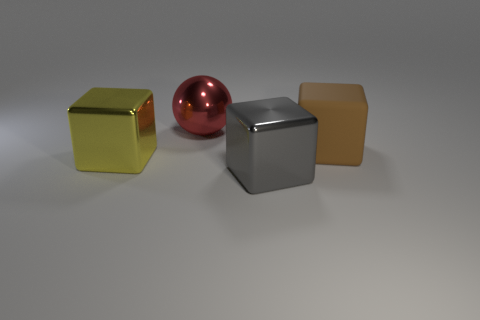Is there anything else that is the same shape as the big brown matte thing?
Provide a short and direct response. Yes. There is a shiny block that is in front of the shiny cube on the left side of the red sphere; how big is it?
Your answer should be compact. Large. What number of small things are rubber blocks or purple shiny objects?
Your answer should be compact. 0. Are there fewer big red balls than cyan blocks?
Your answer should be very brief. No. Are there any other things that have the same size as the red ball?
Provide a short and direct response. Yes. Does the rubber thing have the same color as the ball?
Your answer should be very brief. No. Are there more big red things than big objects?
Make the answer very short. No. How many other objects are the same color as the ball?
Your response must be concise. 0. There is a large object behind the big brown thing; what number of yellow things are in front of it?
Offer a very short reply. 1. There is a yellow metallic block; are there any big yellow things behind it?
Ensure brevity in your answer.  No. 